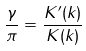Convert formula to latex. <formula><loc_0><loc_0><loc_500><loc_500>\frac { \gamma } { \pi } = \frac { K ^ { \prime } ( k ) } { K ( k ) }</formula> 